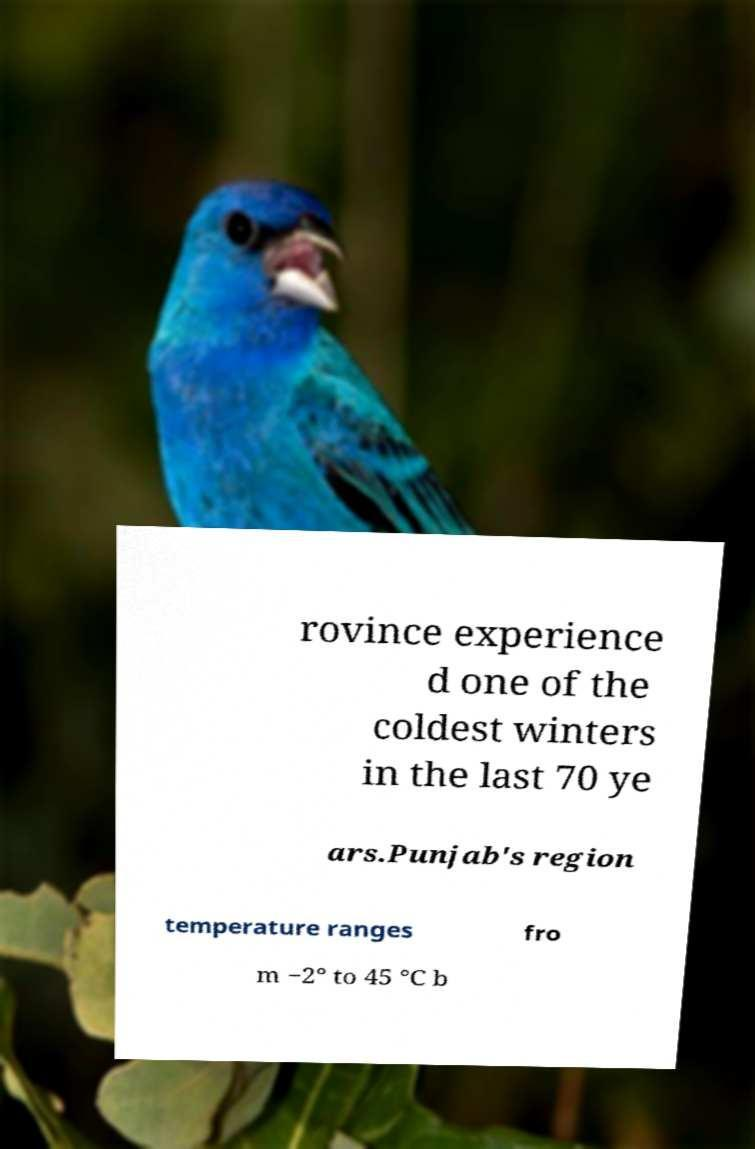I need the written content from this picture converted into text. Can you do that? rovince experience d one of the coldest winters in the last 70 ye ars.Punjab's region temperature ranges fro m −2° to 45 °C b 